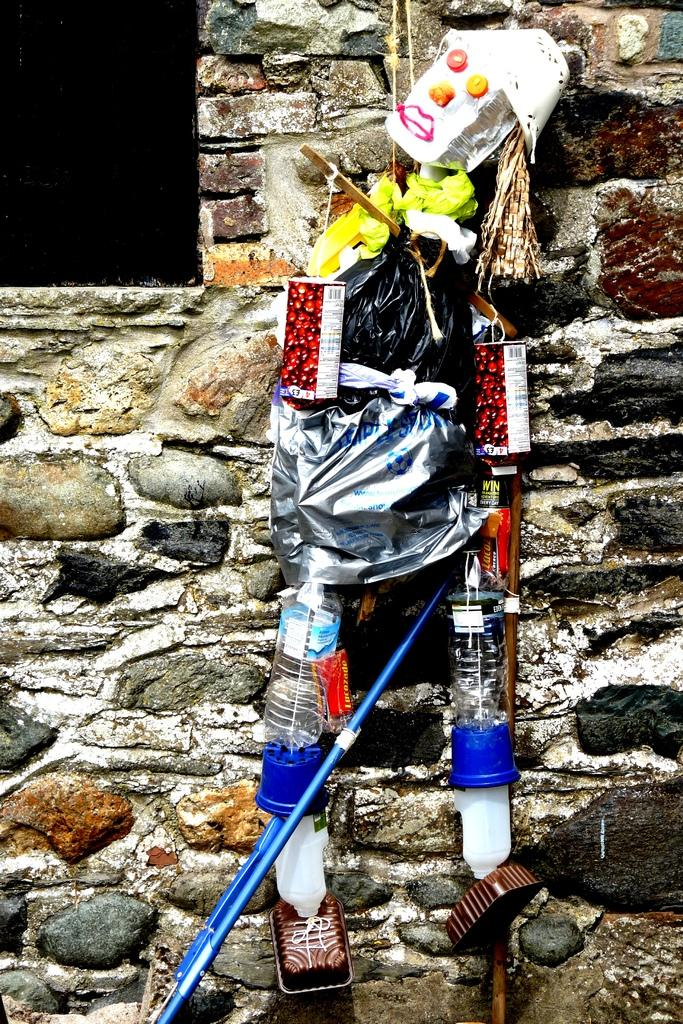What is the main subject of the image? There is an object in the shape of a person in the image. What can be seen in the background of the image? There is a wall in the background of the image. What type of face can be seen expressing disgust in the image? There is no face present in the image, and therefore no expression of disgust can be observed. 